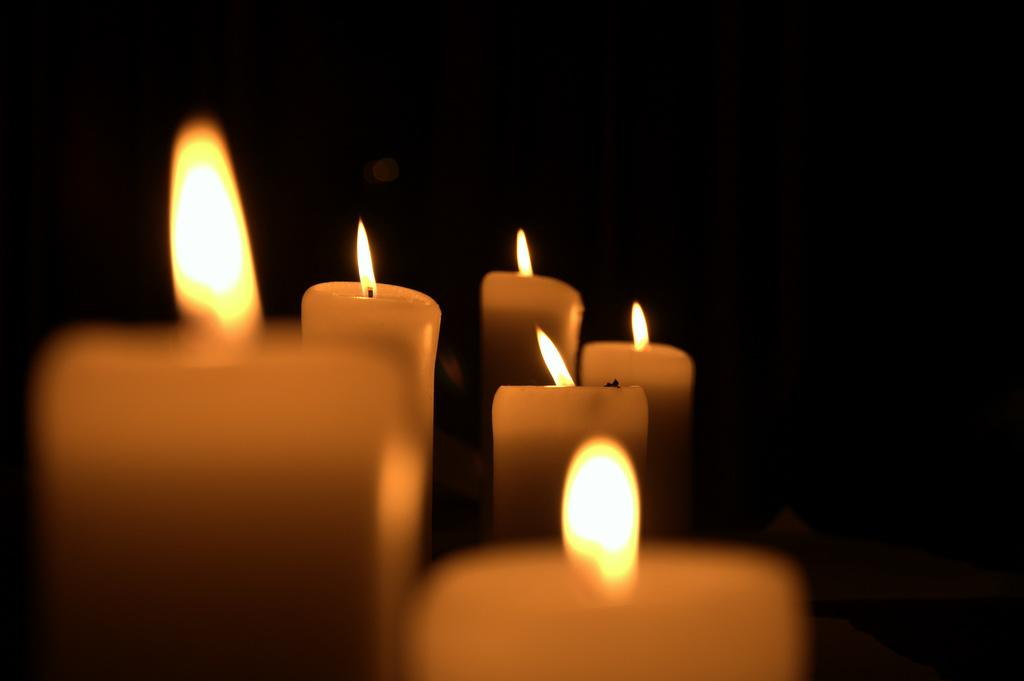What objects can be seen in the image? There are candles in the image. What is the color of the background in the image? The background of the image is black. What nation does the stranger in the image belong to? There is no stranger present in the image, so it is not possible to determine the nation they might belong to. 